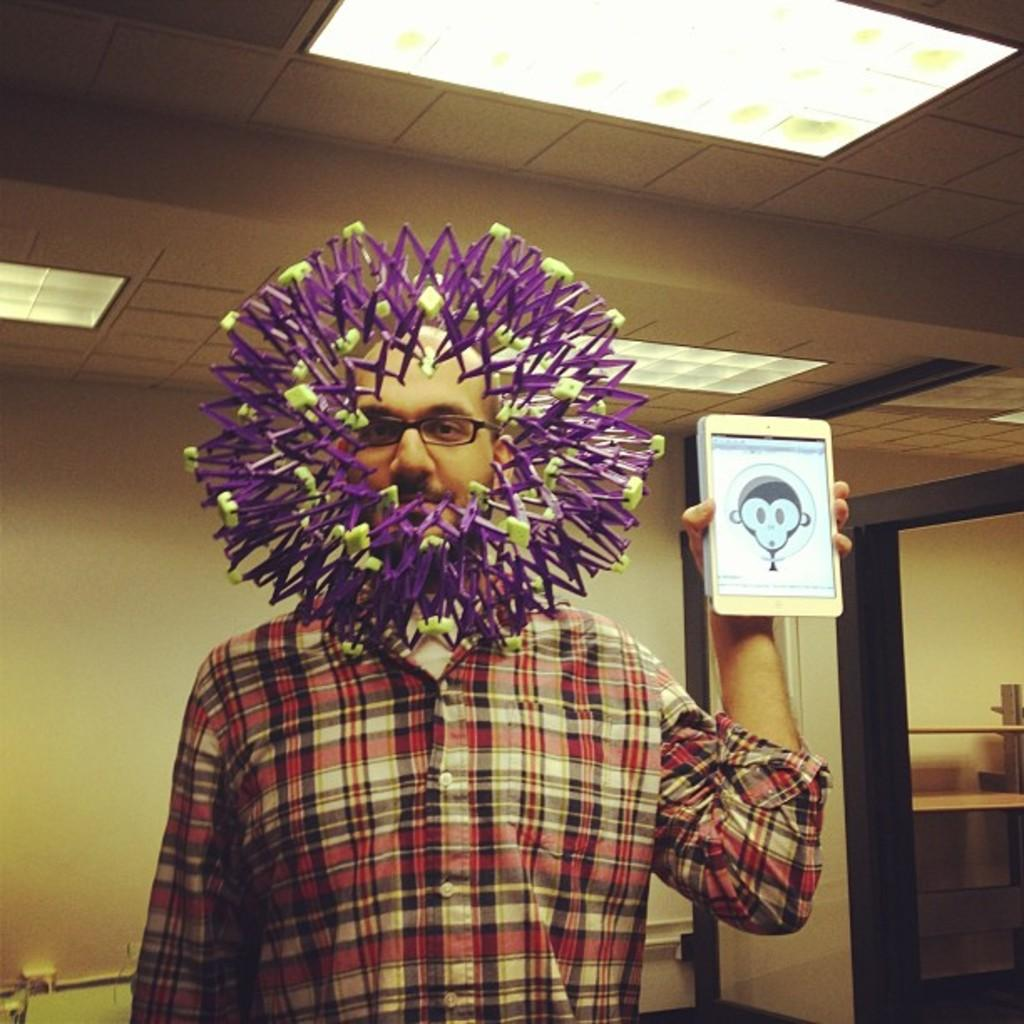What is the man in the image doing? The man is standing in the image. What is the man holding in the image? The man is holding a gadget. What accessory is the man wearing in the image? The man is wearing spectacles. What can be seen in front of the man in the image? There is a decorative object in front of the man. What is visible in the background of the image? There is a wall in the background of the image. What is visible at the top of the image? There are lights visible at the top of the image. How many sisters are swimming in the lake in the image? There is no lake or sisters present in the image. What type of shop can be seen in the background of the image? There is no shop visible in the image; it only shows a wall in the background. 